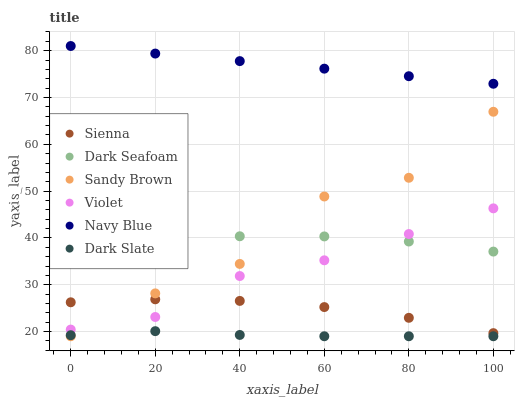Does Dark Slate have the minimum area under the curve?
Answer yes or no. Yes. Does Navy Blue have the maximum area under the curve?
Answer yes or no. Yes. Does Sienna have the minimum area under the curve?
Answer yes or no. No. Does Sienna have the maximum area under the curve?
Answer yes or no. No. Is Navy Blue the smoothest?
Answer yes or no. Yes. Is Sandy Brown the roughest?
Answer yes or no. Yes. Is Sienna the smoothest?
Answer yes or no. No. Is Sienna the roughest?
Answer yes or no. No. Does Dark Slate have the lowest value?
Answer yes or no. Yes. Does Sienna have the lowest value?
Answer yes or no. No. Does Navy Blue have the highest value?
Answer yes or no. Yes. Does Sienna have the highest value?
Answer yes or no. No. Is Dark Slate less than Sienna?
Answer yes or no. Yes. Is Navy Blue greater than Sandy Brown?
Answer yes or no. Yes. Does Violet intersect Sandy Brown?
Answer yes or no. Yes. Is Violet less than Sandy Brown?
Answer yes or no. No. Is Violet greater than Sandy Brown?
Answer yes or no. No. Does Dark Slate intersect Sienna?
Answer yes or no. No. 